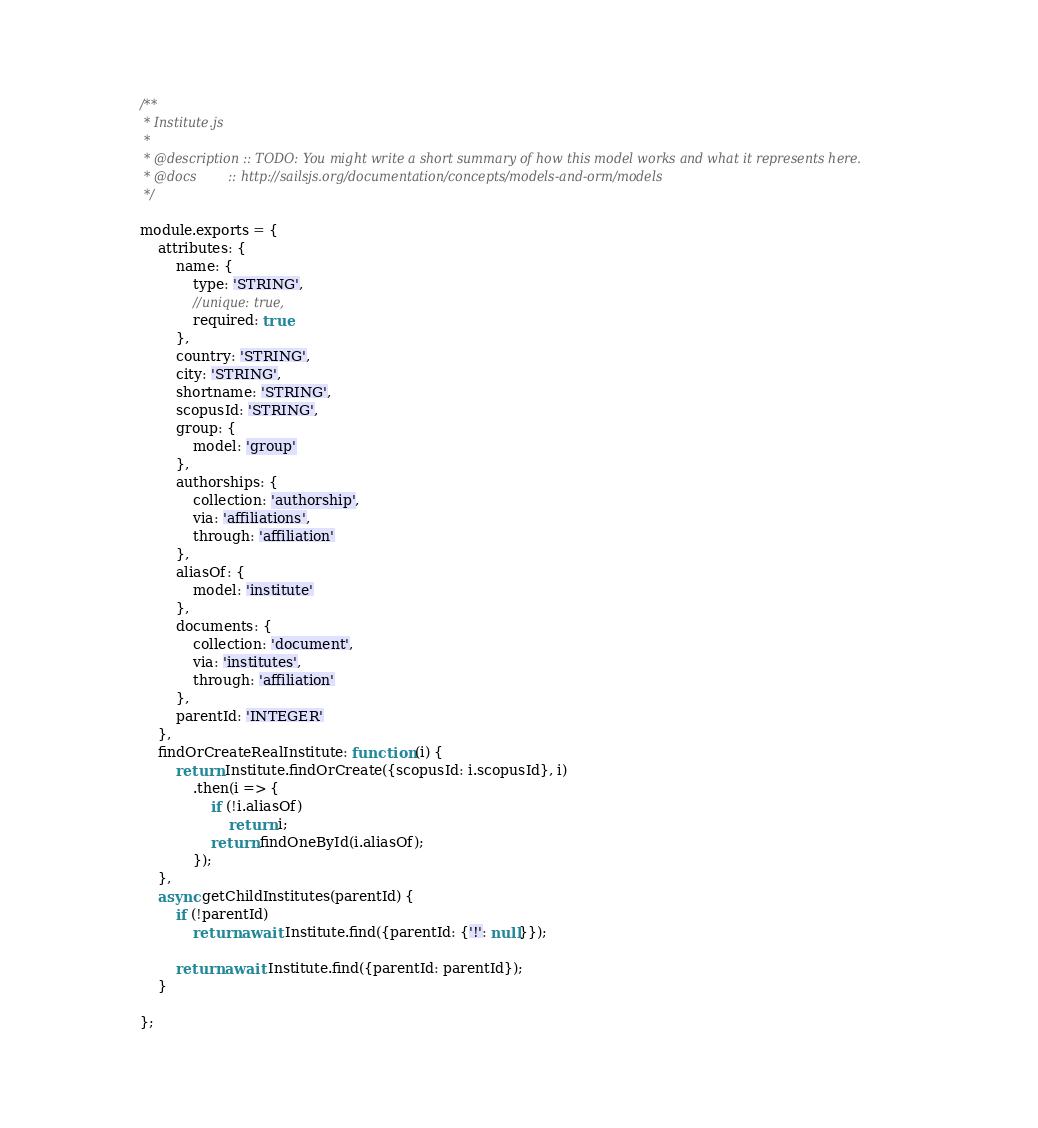<code> <loc_0><loc_0><loc_500><loc_500><_JavaScript_>/**
 * Institute.js
 *
 * @description :: TODO: You might write a short summary of how this model works and what it represents here.
 * @docs        :: http://sailsjs.org/documentation/concepts/models-and-orm/models
 */

module.exports = {
    attributes: {
        name: {
            type: 'STRING',
            //unique: true,
            required: true
        },
        country: 'STRING',
        city: 'STRING',
        shortname: 'STRING',
        scopusId: 'STRING',
        group: {
            model: 'group'
        },
        authorships: {
            collection: 'authorship',
            via: 'affiliations',
            through: 'affiliation'
        },
        aliasOf: {
            model: 'institute'
        },
        documents: {
            collection: 'document',
            via: 'institutes',
            through: 'affiliation'
        },
        parentId: 'INTEGER'
    },
    findOrCreateRealInstitute: function (i) {
        return Institute.findOrCreate({scopusId: i.scopusId}, i)
            .then(i => {
                if (!i.aliasOf)
                    return i;
                return findOneById(i.aliasOf);
            });
    },
    async getChildInstitutes(parentId) {
        if (!parentId)
            return await Institute.find({parentId: {'!': null}});

        return await Institute.find({parentId: parentId});
    }

};

</code> 